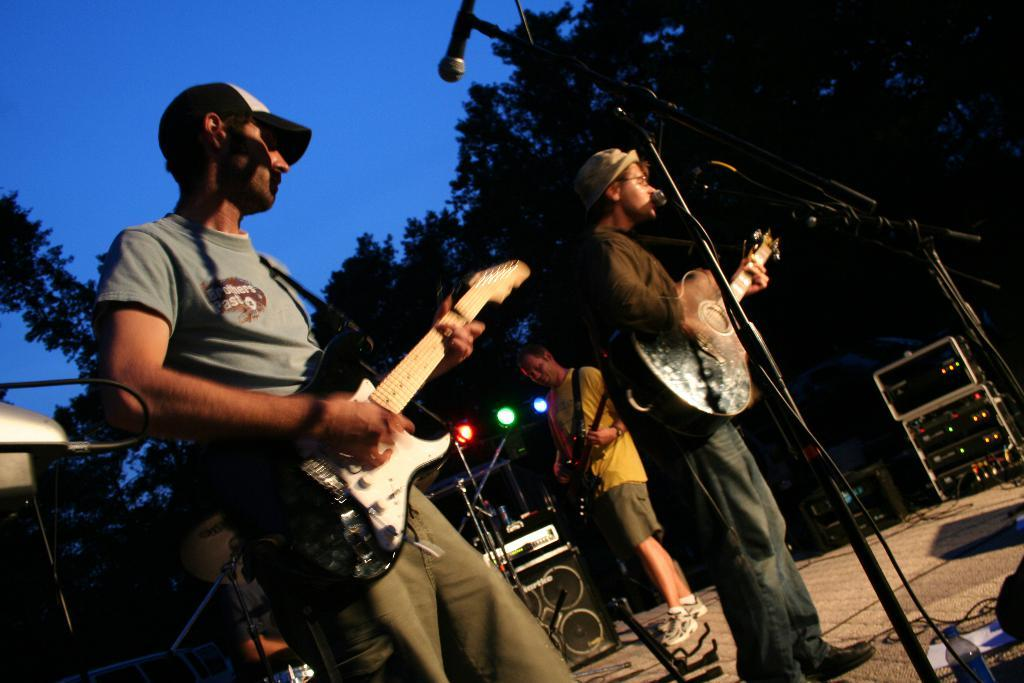What is happening on stage in the image? There is a group of people on stage, and they are standing with guitars. What are the people on stage possibly doing? They might be performing a musical act, as they are holding guitars and there is a microphone in front of them. What can be seen in the background of the stage? Trees are visible in the background. What equipment is present on stage to enhance the performance? There are focusing lights, sound boxes, and electronic devices on stage. What type of jelly can be seen on the guitar strings in the image? There is no jelly present on the guitar strings or anywhere else in the image. 